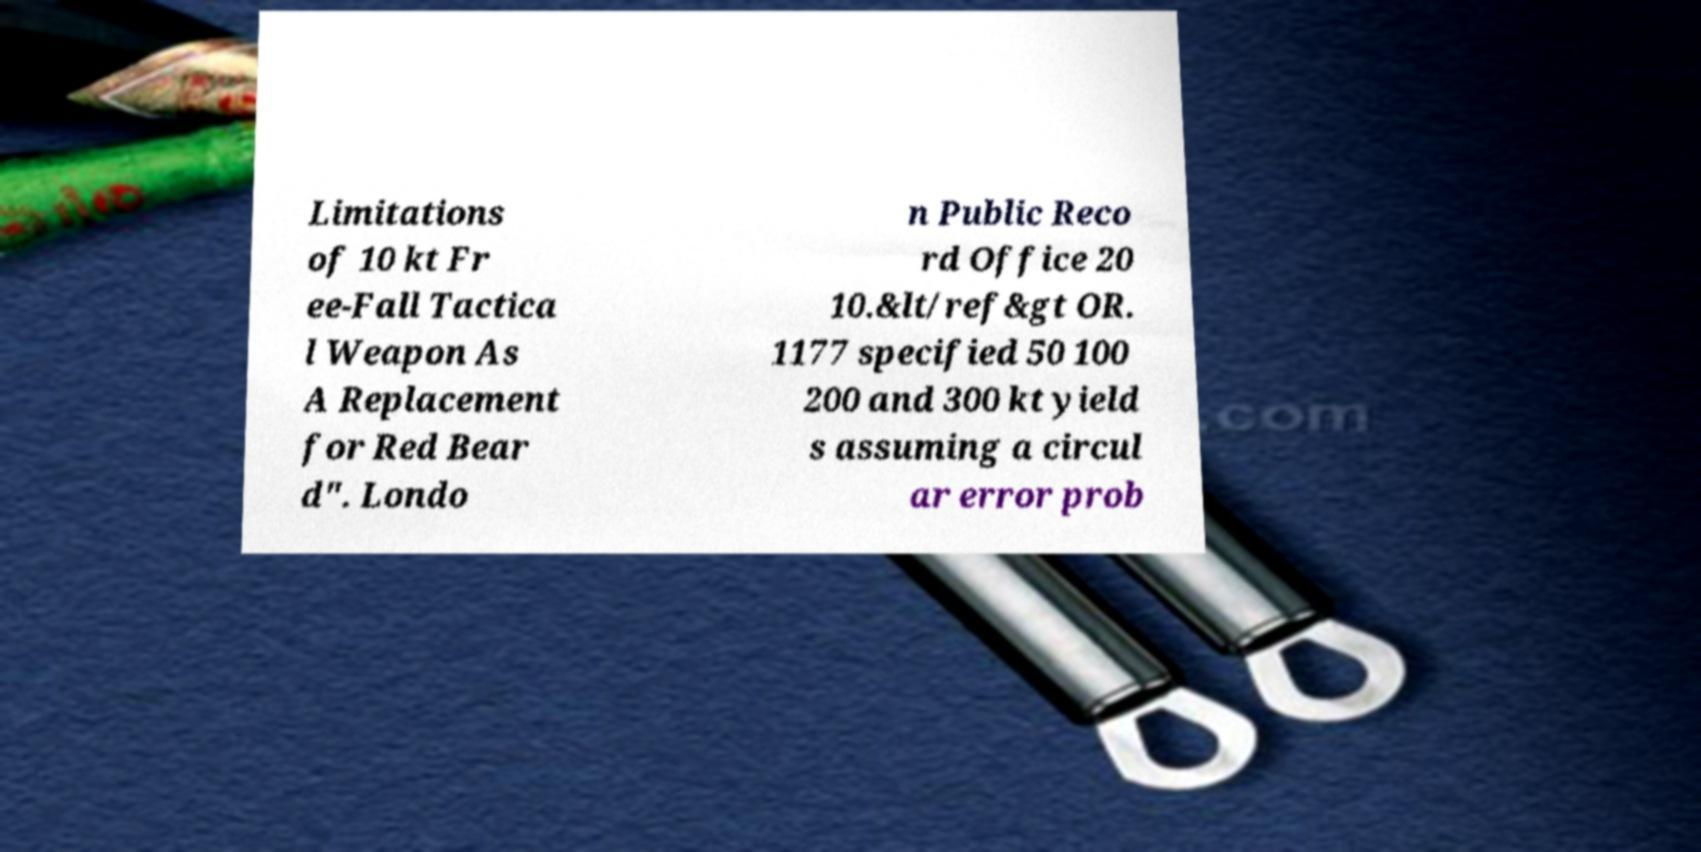Can you read and provide the text displayed in the image?This photo seems to have some interesting text. Can you extract and type it out for me? Limitations of 10 kt Fr ee-Fall Tactica l Weapon As A Replacement for Red Bear d". Londo n Public Reco rd Office 20 10.&lt/ref&gt OR. 1177 specified 50 100 200 and 300 kt yield s assuming a circul ar error prob 